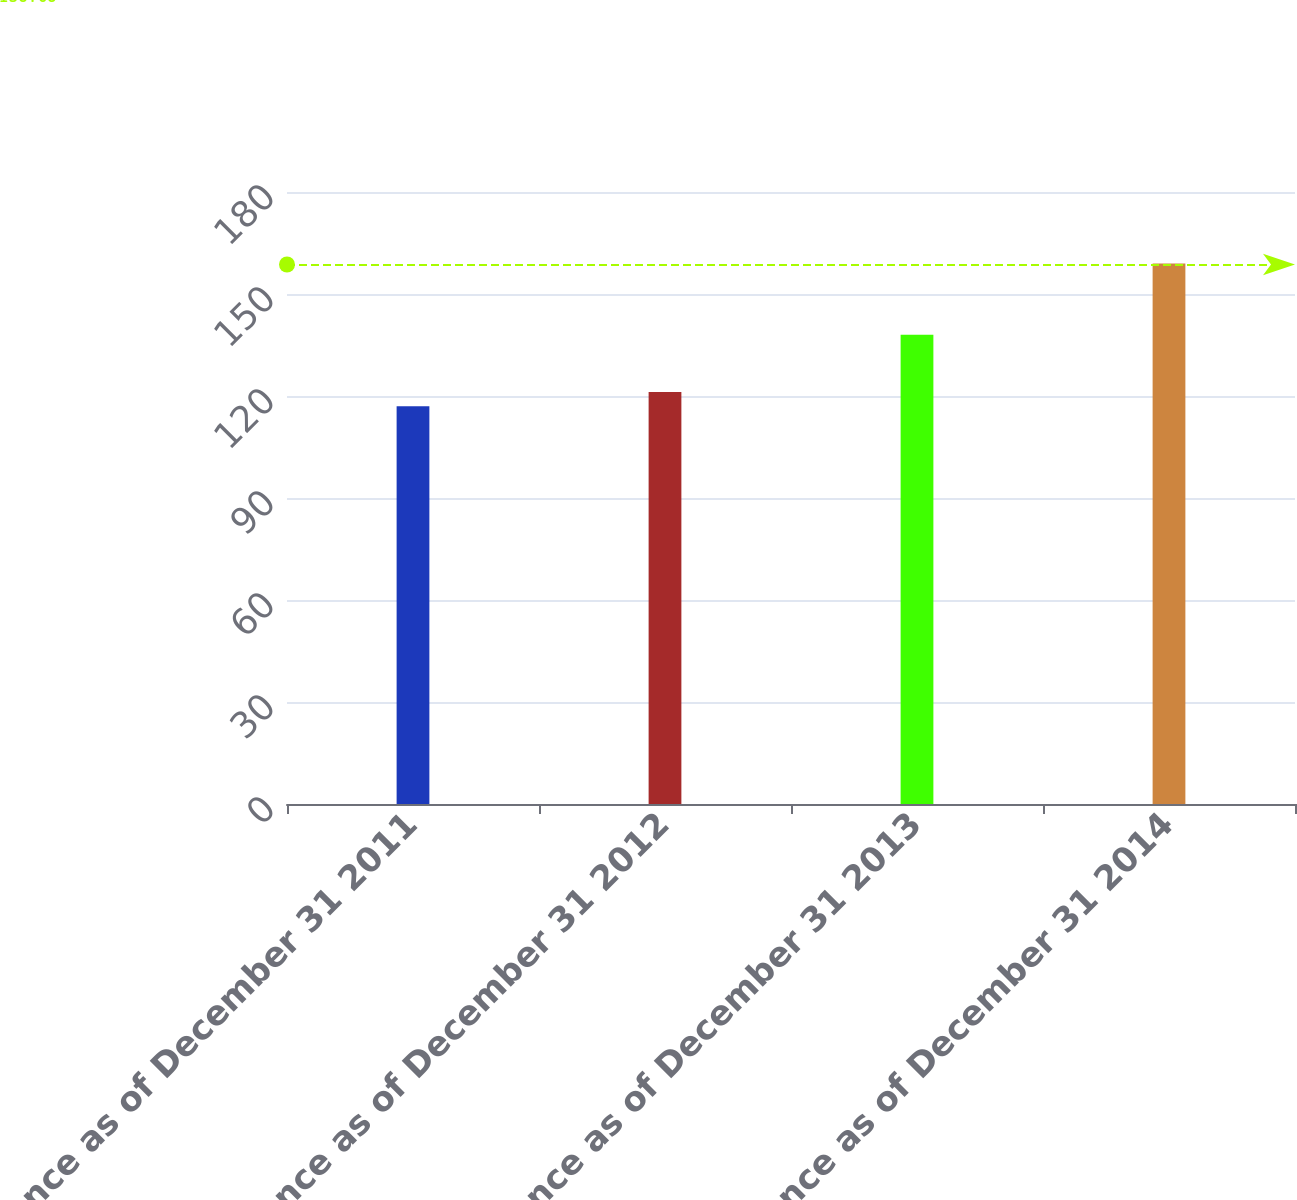<chart> <loc_0><loc_0><loc_500><loc_500><bar_chart><fcel>Balance as of December 31 2011<fcel>Balance as of December 31 2012<fcel>Balance as of December 31 2013<fcel>Balance as of December 31 2014<nl><fcel>117<fcel>121.2<fcel>138<fcel>159<nl></chart> 